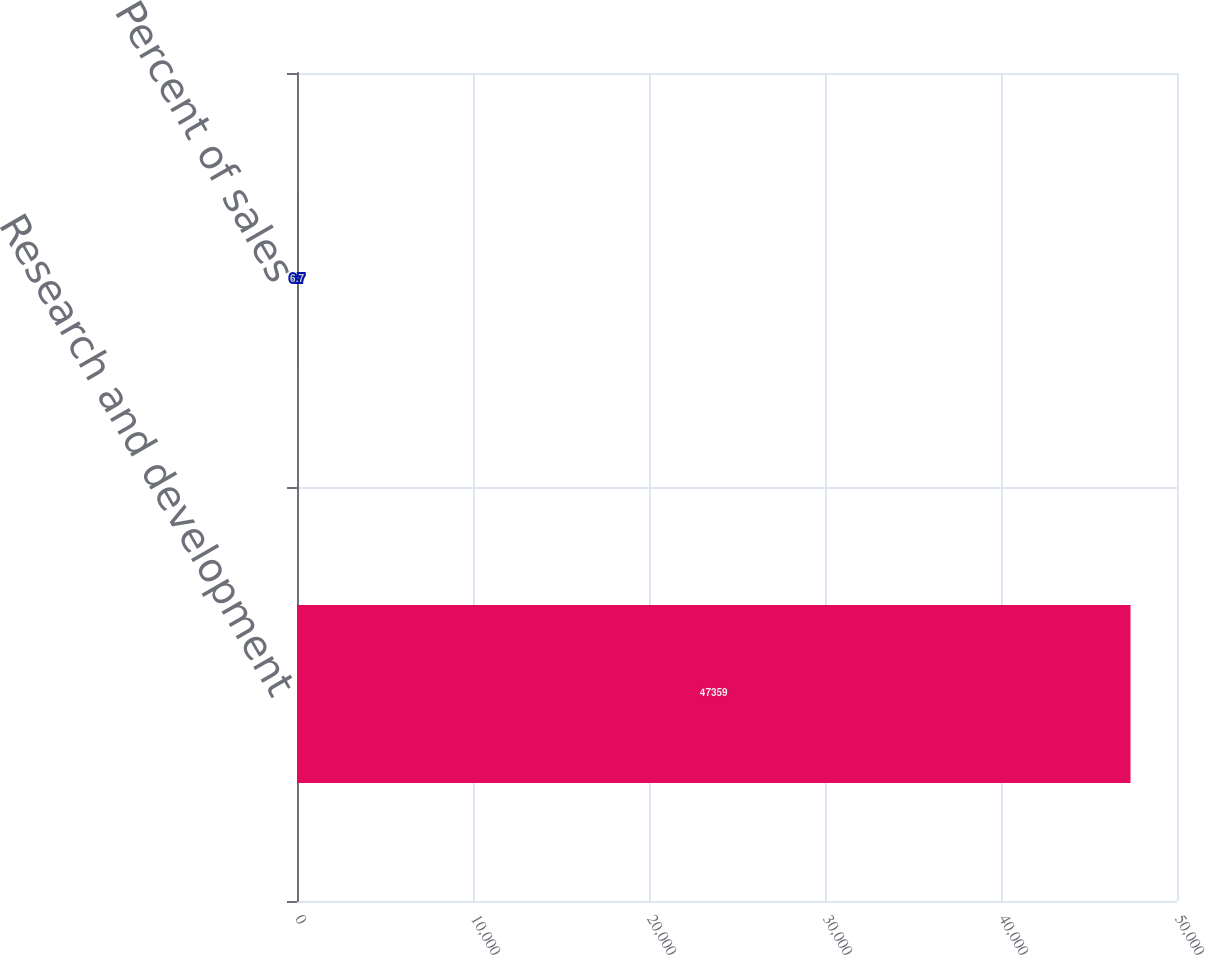<chart> <loc_0><loc_0><loc_500><loc_500><bar_chart><fcel>Research and development<fcel>Percent of sales<nl><fcel>47359<fcel>6.7<nl></chart> 